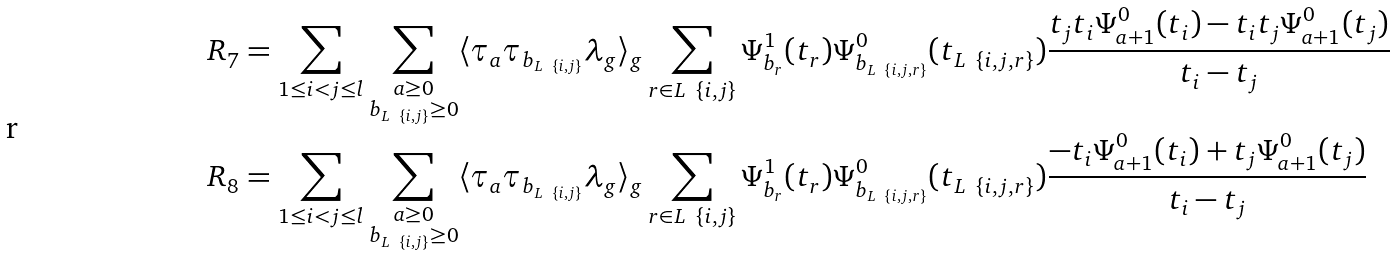Convert formula to latex. <formula><loc_0><loc_0><loc_500><loc_500>& R _ { 7 } = \sum _ { 1 \leq i < j \leq l } \sum _ { \substack { a \geq 0 \\ b _ { L \ \{ i , j \} } \geq 0 } } \langle \tau _ { a } \tau _ { b _ { L \ \{ i , j \} } } \lambda _ { g } \rangle _ { g } \sum _ { r \in L \ \{ i , j \} } \Psi _ { b _ { r } } ^ { 1 } ( t _ { r } ) \Psi _ { b _ { L \ \{ i , j , r \} } } ^ { 0 } ( t _ { L \ \{ i , j , r \} } ) \frac { t _ { j } t _ { i } \Psi _ { a + 1 } ^ { 0 } ( t _ { i } ) - t _ { i } t _ { j } \Psi _ { a + 1 } ^ { 0 } ( t _ { j } ) } { t _ { i } - t _ { j } } \\ & R _ { 8 } = \sum _ { 1 \leq i < j \leq l } \sum _ { \substack { a \geq 0 \\ b _ { L \ \{ i , j \} } \geq 0 } } \langle \tau _ { a } \tau _ { b _ { L \ \{ i , j \} } } \lambda _ { g } \rangle _ { g } \sum _ { r \in L \ \{ i , j \} } \Psi _ { b _ { r } } ^ { 1 } ( t _ { r } ) \Psi _ { b _ { L \ \{ i , j , r \} } } ^ { 0 } ( t _ { L \ \{ i , j , r \} } ) \frac { - t _ { i } \Psi _ { a + 1 } ^ { 0 } ( t _ { i } ) + t _ { j } \Psi _ { a + 1 } ^ { 0 } ( t _ { j } ) } { t _ { i } - t _ { j } }</formula> 